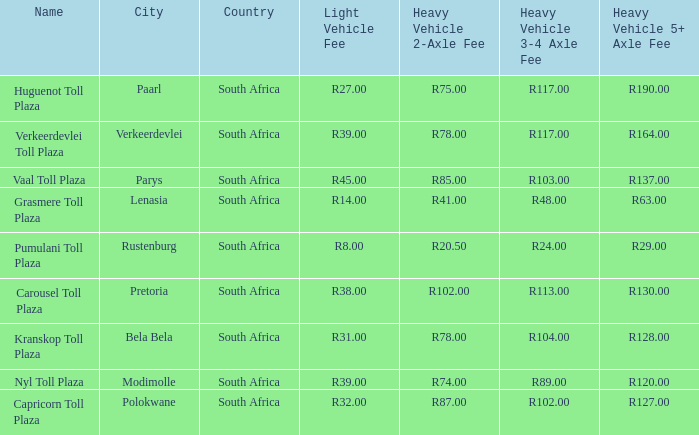What is the toll for light vehicles at the plaza between bela bela and modimolle? R31.00. 